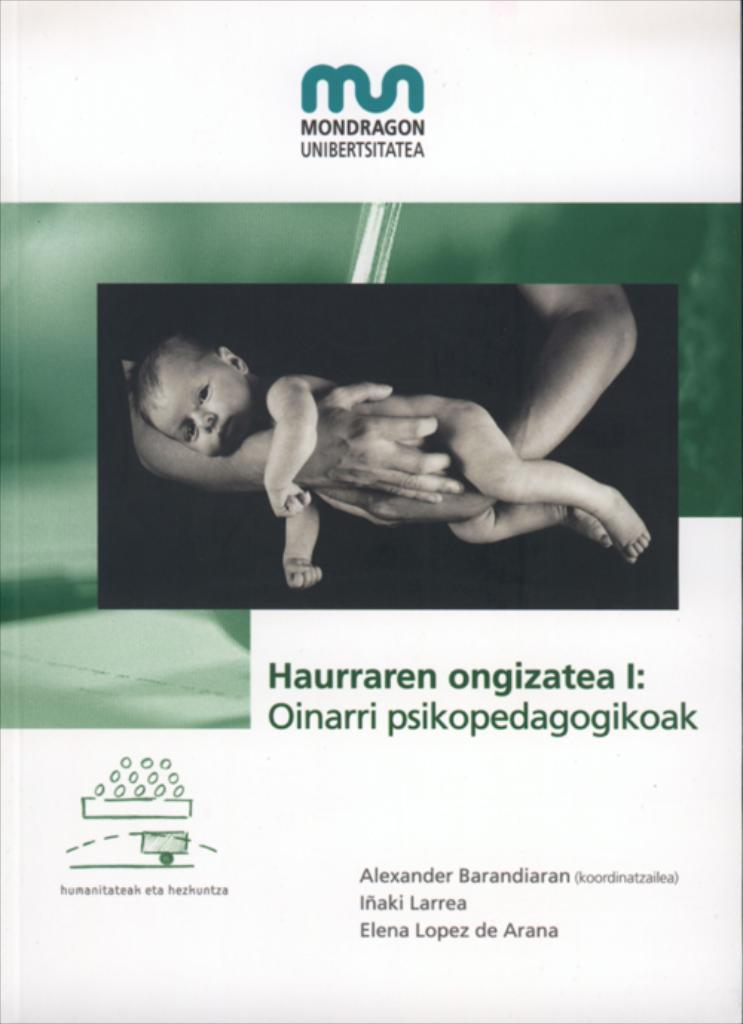What type of visual is the image? The image is a poster. What is happening in the center of the poster? There is a person holding a baby in the center of the poster. Where can text be found on the poster? There is text at the top and bottom of the poster. What is located at the top of the poster? There is a logo at the top of the poster. What type of pen is the goat using to write on the poster? There is no goat or pen present in the image; it features a person holding a baby and text on a poster. 